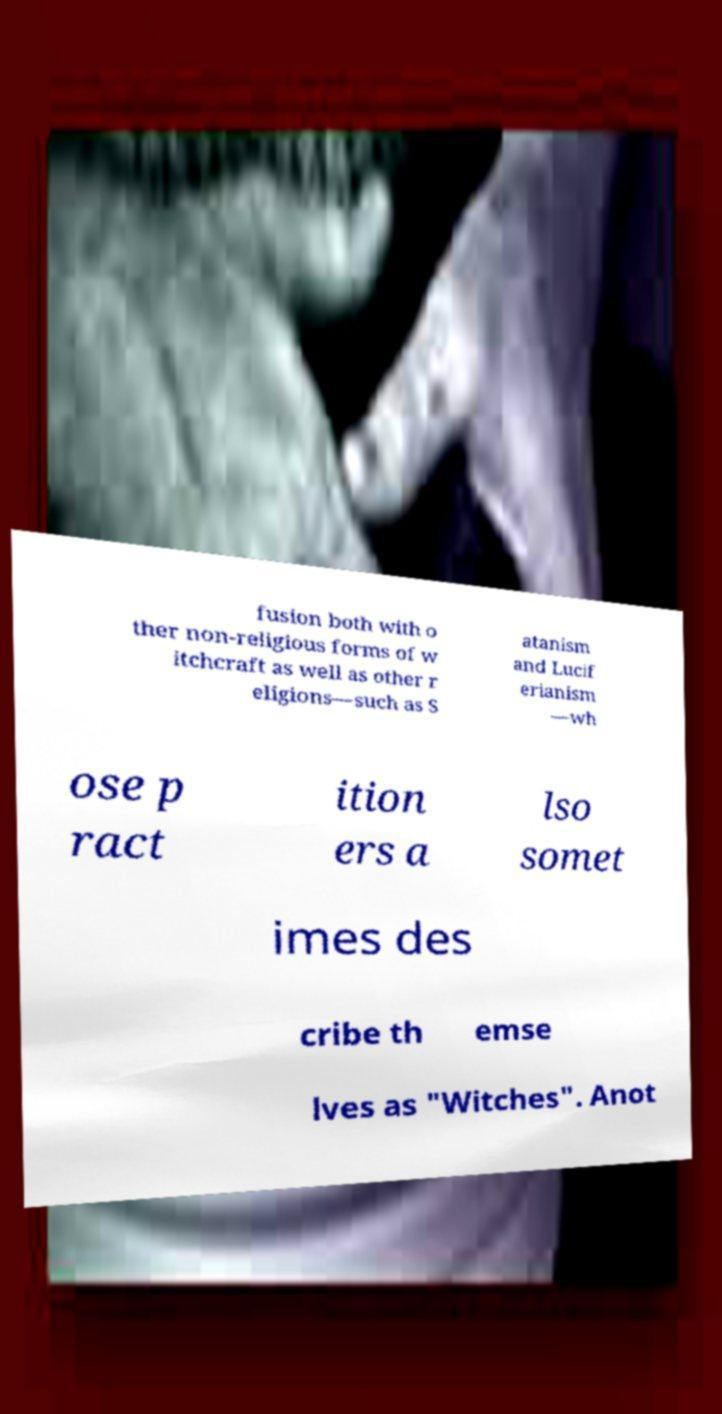There's text embedded in this image that I need extracted. Can you transcribe it verbatim? fusion both with o ther non-religious forms of w itchcraft as well as other r eligions—such as S atanism and Lucif erianism —wh ose p ract ition ers a lso somet imes des cribe th emse lves as "Witches". Anot 